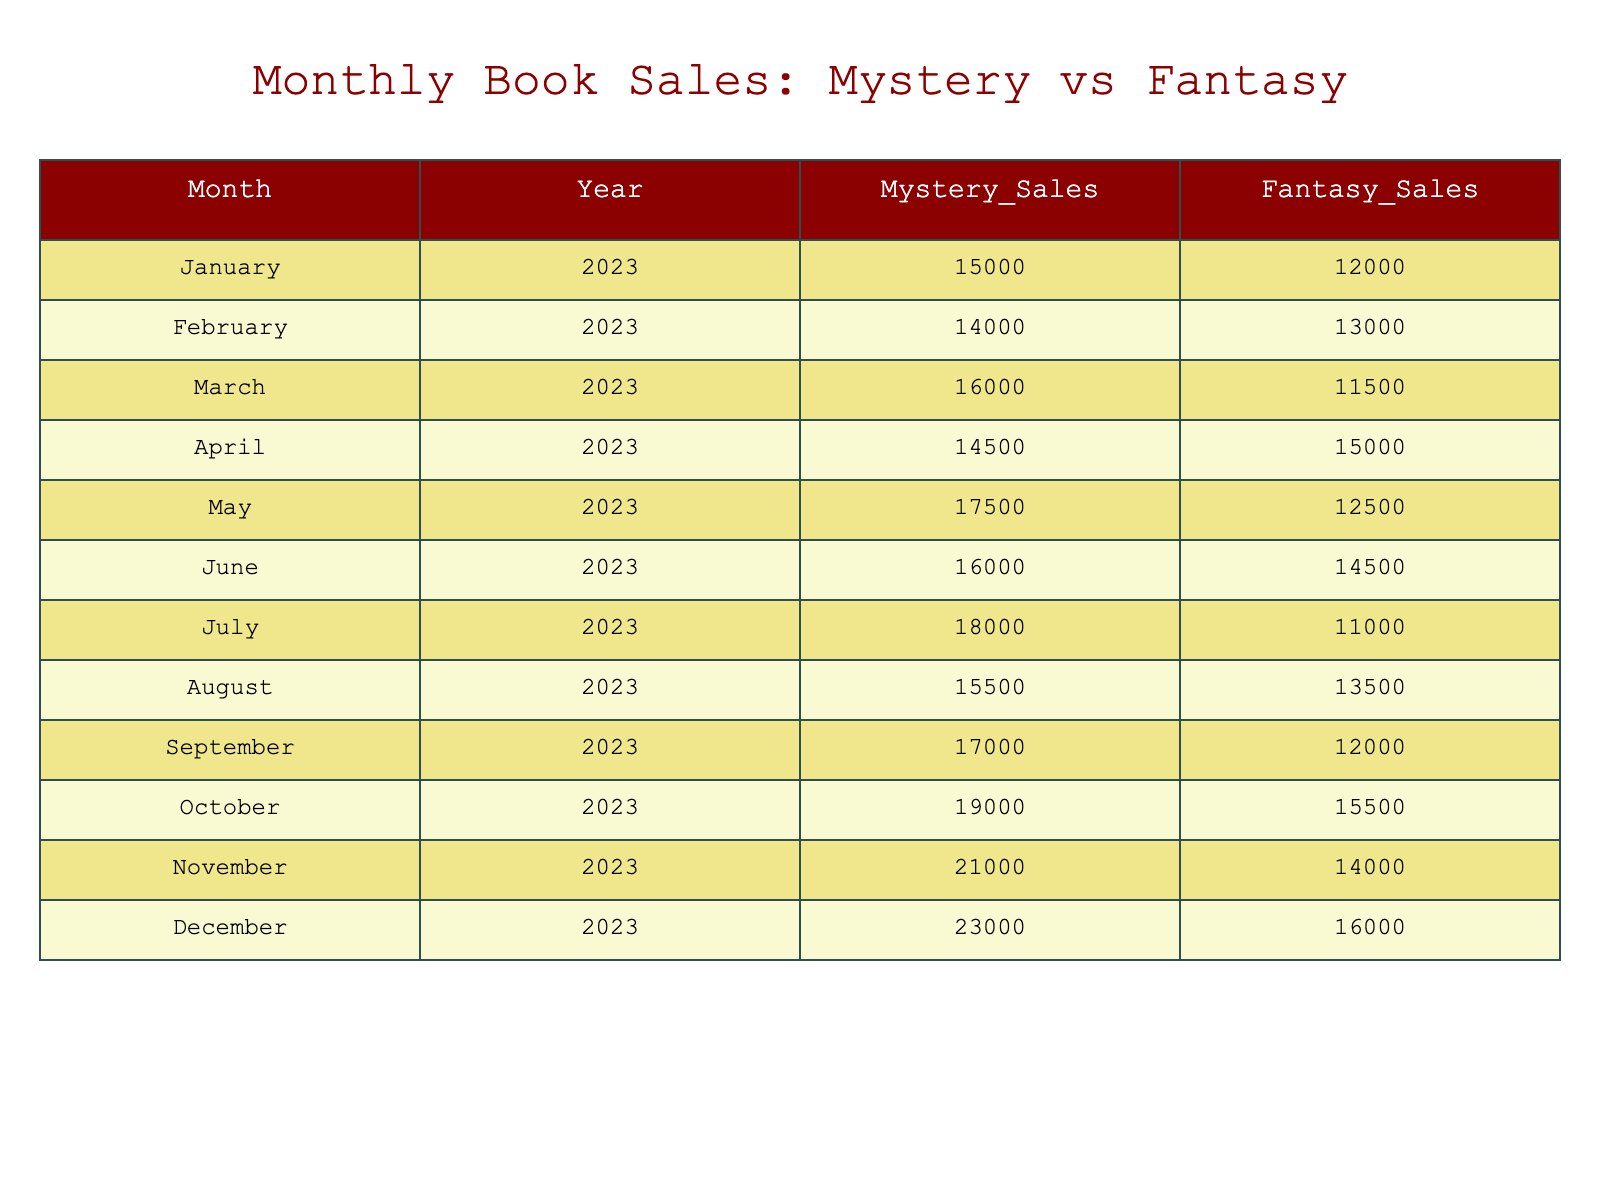What were the mystery sales in December 2023? The table shows that in December 2023, the mystery sales were 23000.
Answer: 23000 What was the highest fantasy sales recorded in 2023? By reviewing the fantasy sales column, the highest value is 16000 in December 2023.
Answer: 16000 What is the average monthly mystery sales for 2023? To find the average, sum the mystery sales for all months (15000 + 14000 + 16000 + 14500 + 17500 + 16000 + 18000 + 15500 + 17000 + 19000 + 21000 + 23000 = 190500), then divide by 12 (190500/12 = 15875).
Answer: 15875 Did fantasy sales exceed mystery sales in any month? Comparing the sales for each month, they exceeded in April 2023 (15000 vs. 14500).
Answer: Yes What was the difference in sales between mystery and fantasy in July 2023? In July 2023, mystery sales were 18000 and fantasy sales were 11000. The difference is 18000 - 11000 = 7000.
Answer: 7000 Which genre had the consistently higher sales in the last six months of 2023? Reviewing the last six months, in November and December, mystery sales were higher (21000 and 23000) compared to fantasy's sales (14000 and 16000), confirming mystery sales were consistently higher.
Answer: Mystery What was the total sales for both genres in March 2023? Add both genres’ sales for March: Mystery (16000) + Fantasy (11500) = 27500 total.
Answer: 27500 Which month had the largest sales for mystery genre, and how much was it? December 2023 had the largest sales for the mystery genre, which was 23000.
Answer: December 2023, 23000 Was there a month in 2023 when fantasy sales were over 15000? Checking the fantasy sales figures, only April (15000) and December (16000) had sales at or above 15000.
Answer: Yes 